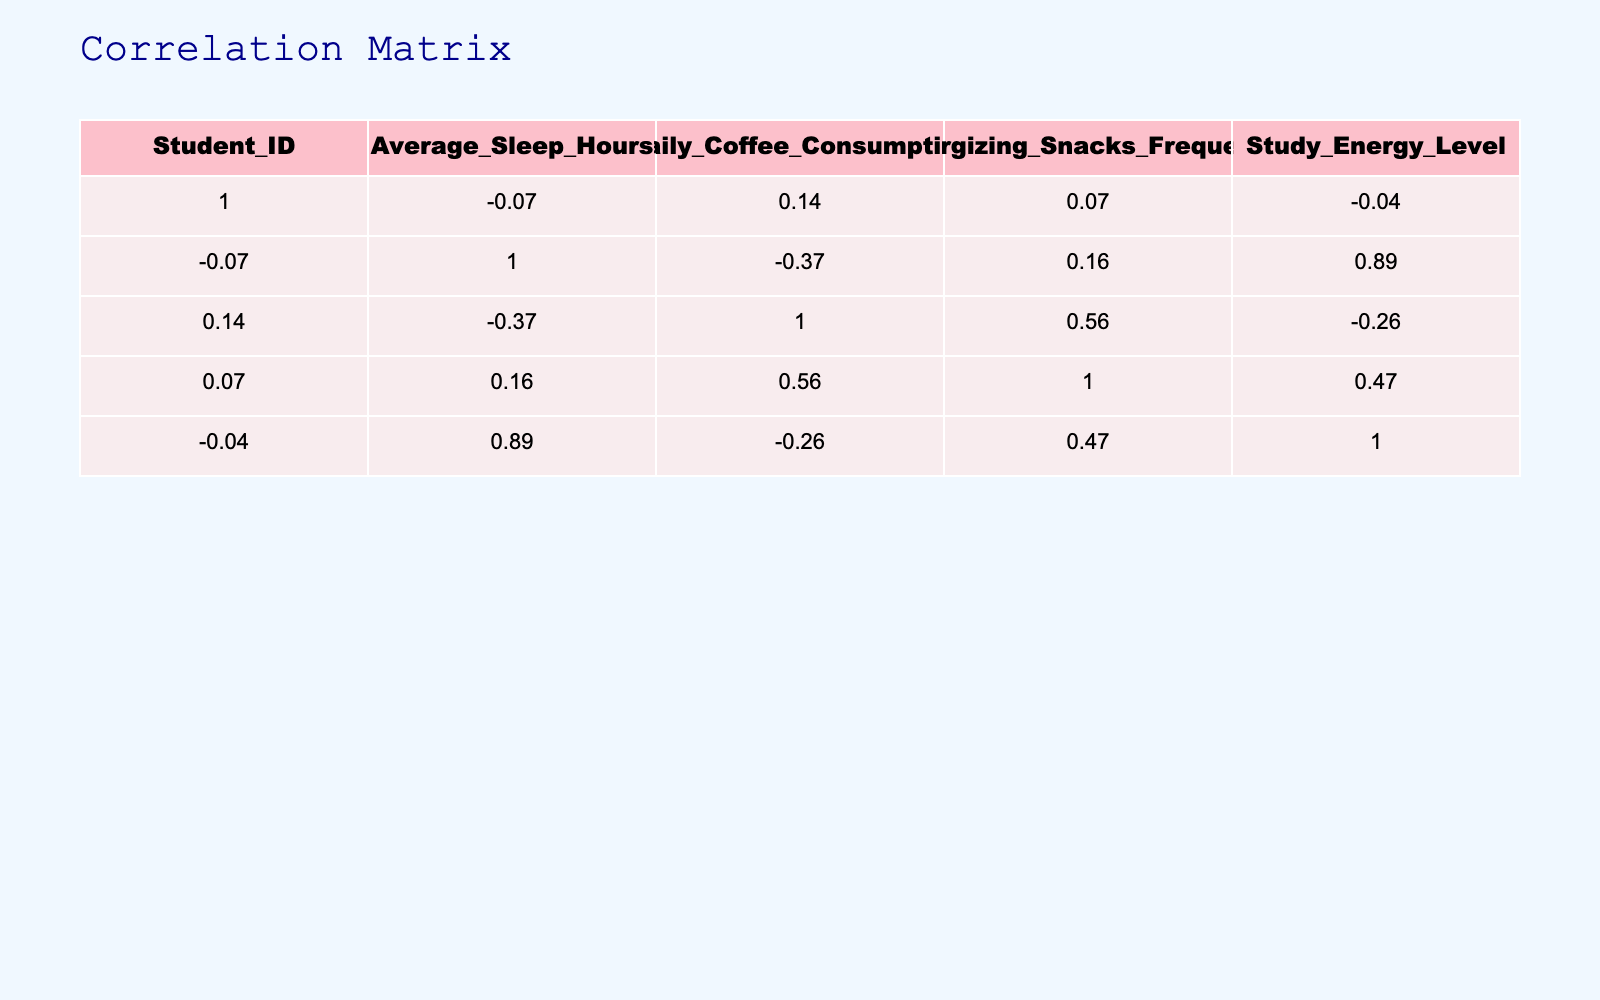What is the correlation between Average Sleep Hours and Study Energy Level? The correlation coefficient from the table indicates that as Average Sleep Hours increase, the Study Energy Level tends to increase as well, which points to a positive correlation.
Answer: Positive Which dietary habit has the highest average Study Energy Level? By checking the average Study Energy Level for each Dietary Habit, we see that the Vegetarian diet has the highest value of 9, indicating it is the most effective for energy during exam weeks.
Answer: Vegetarian Is it true that high-carb diets correlate with higher energy levels? The correlation value for the High-carb diet in relation to Study Energy Level is not high; thus, it is false to say that high-carb diets directly correlate with higher energy levels.
Answer: False What is the average Daily Coffee Consumption for students with a Balanced dietary habit? There is only one student in the Balanced category with a Daily Coffee Consumption of 1, which means the average is also 1 for this group.
Answer: 1 Which dietary habit category has the lowest frequency of Energizing Snacks? By examining the data for each dietary habit, it’s evident that the Fast-food diet is associated with the lowest frequency of Energizing Snacks, which is only 1.
Answer: Fast-food What is the sum of Average Sleep Hours for all students who consume more than two cups of coffee daily? Students who consume more than two cups of coffee daily are Students IDs 5 and 10. Their Average Sleep Hours are 5 and 4, respectively. The sum is 5 + 4 = 9.
Answer: 9 Are students consuming more than two cups of coffee generally less energized? Looking at the Study Energy Levels for those who consume more than two cups of coffee—Student IDs 5 and 10, with energy levels of 6 and 5, it's evident they have lower energy levels compared to other habits. Hence, it’s true.
Answer: True What's the median value of Study Energy Levels across all dietary habits? Arranging the Study Energy Levels in order: 3, 4, 4, 5, 5, 6, 7, 7, 8, 9, we find there are 10 values, so the median is the average of the 5th and 6th values: (5 + 6) / 2 = 5.5.
Answer: 5.5 How much difference is there in Study Energy Level between Low-carb and High-protein diets? The Study Energy Level for Low-carb is 4, and for High-protein it is 5. Calculating the difference gives us 5 - 4 = 1.
Answer: 1 